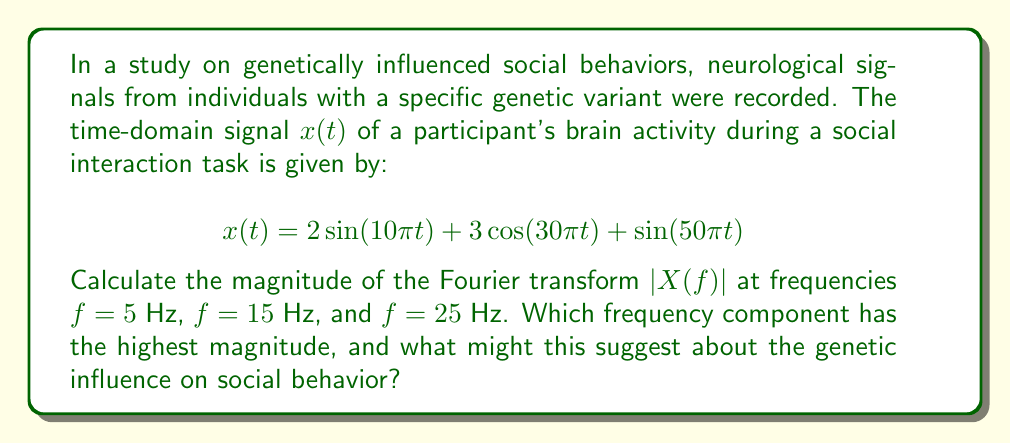Could you help me with this problem? To solve this problem, we need to follow these steps:

1) The Fourier transform of a sinusoidal signal is given by:

   For $\sin(2\pi f_0 t)$: $X(f) = \frac{i}{2}[\delta(f-f_0) - \delta(f+f_0)]$
   For $\cos(2\pi f_0 t)$: $X(f) = \frac{1}{2}[\delta(f-f_0) + \delta(f+f_0)]$

   Where $\delta$ is the Dirac delta function.

2) Our signal has three components:
   
   $2\sin(10\pi t)$ with $f_0 = 5$ Hz
   $3\cos(30\pi t)$ with $f_0 = 15$ Hz
   $\sin(50\pi t)$ with $f_0 = 25$ Hz

3) The Fourier transform of our signal is:

   $$X(f) = i[\delta(f-5) - \delta(f+5)] + \frac{3}{2}[\delta(f-15) + \delta(f+15)] + \frac{i}{2}[\delta(f-25) - \delta(f+25)]$$

4) The magnitude of the Fourier transform $|X(f)|$ at each frequency:

   At $f = 5$ Hz: $|X(5)| = |i| = 1$
   At $f = 15$ Hz: $|X(15)| = |\frac{3}{2}| = 1.5$
   At $f = 25$ Hz: $|X(25)| = |\frac{i}{2}| = 0.5$

5) The frequency component with the highest magnitude is at 15 Hz with a magnitude of 1.5.

This suggests that the 15 Hz component, corresponding to the $3\cos(30\pi t)$ term in the original signal, is the most dominant in the neurological signal during the social interaction task. In the context of genetically influenced social behaviors, this could indicate that individuals with this specific genetic variant show increased neural activity in the frequency range associated with social cognition or emotional processing (often in the beta frequency range, which includes 15 Hz). This finding might suggest a genetic influence on the neural processes underlying social behavior, potentially affecting how these individuals perceive and respond to social stimuli.
Answer: The magnitude of the Fourier transform $|X(f)|$ at the given frequencies are:

$f = 5$ Hz: $|X(5)| = 1$
$f = 15$ Hz: $|X(15)| = 1.5$
$f = 25$ Hz: $|X(25)| = 0.5$

The frequency component with the highest magnitude is 15 Hz, suggesting a potential genetic influence on neural processes related to social cognition or emotional processing. 